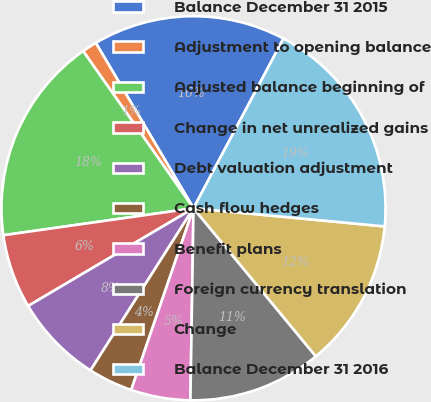Convert chart. <chart><loc_0><loc_0><loc_500><loc_500><pie_chart><fcel>Balance December 31 2015<fcel>Adjustment to opening balance<fcel>Adjusted balance beginning of<fcel>Change in net unrealized gains<fcel>Debt valuation adjustment<fcel>Cash flow hedges<fcel>Benefit plans<fcel>Foreign currency translation<fcel>Change<fcel>Balance December 31 2016<nl><fcel>16.25%<fcel>1.25%<fcel>17.5%<fcel>6.25%<fcel>7.5%<fcel>3.75%<fcel>5.0%<fcel>11.25%<fcel>12.5%<fcel>18.75%<nl></chart> 